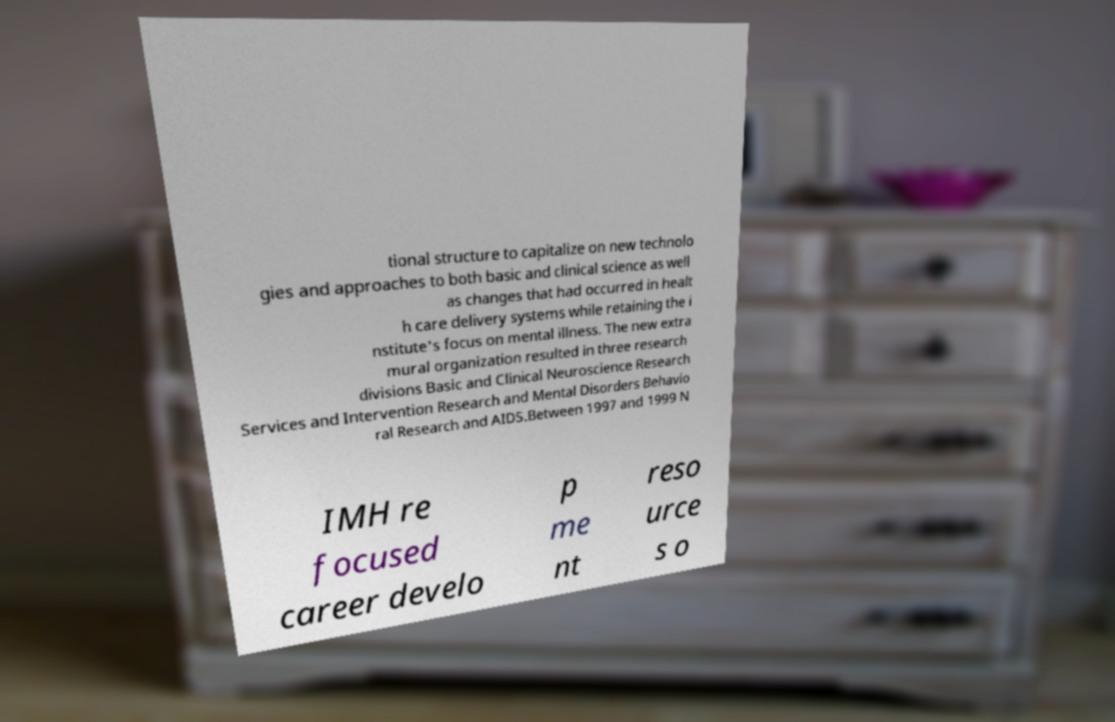Can you accurately transcribe the text from the provided image for me? tional structure to capitalize on new technolo gies and approaches to both basic and clinical science as well as changes that had occurred in healt h care delivery systems while retaining the i nstitute's focus on mental illness. The new extra mural organization resulted in three research divisions Basic and Clinical Neuroscience Research Services and Intervention Research and Mental Disorders Behavio ral Research and AIDS.Between 1997 and 1999 N IMH re focused career develo p me nt reso urce s o 